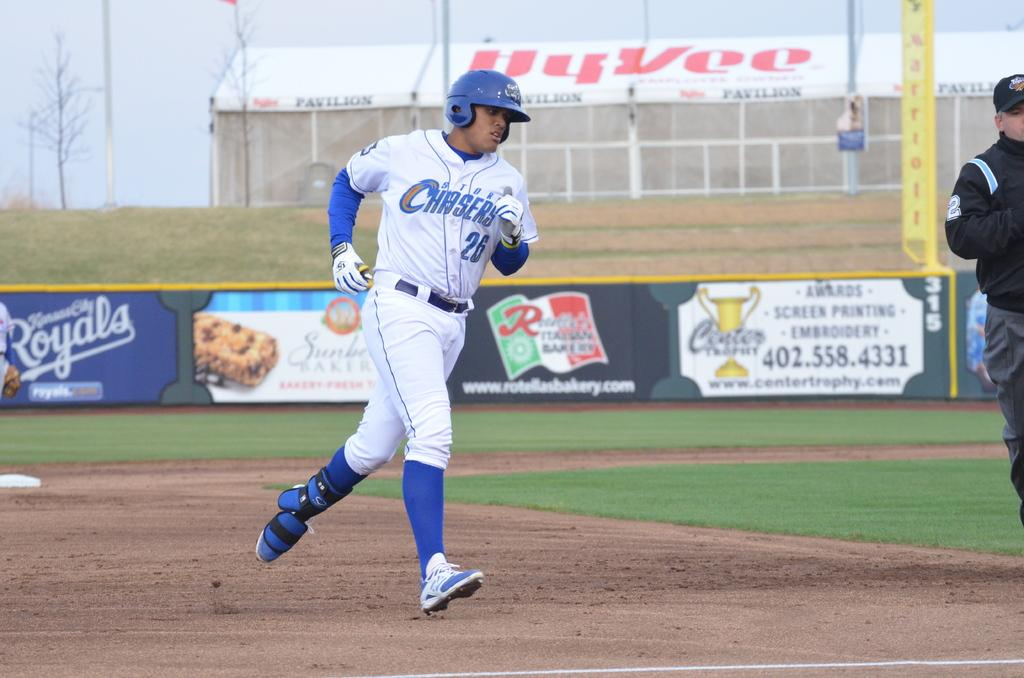<image>
Provide a brief description of the given image. the word Chasers is on the white jersey 